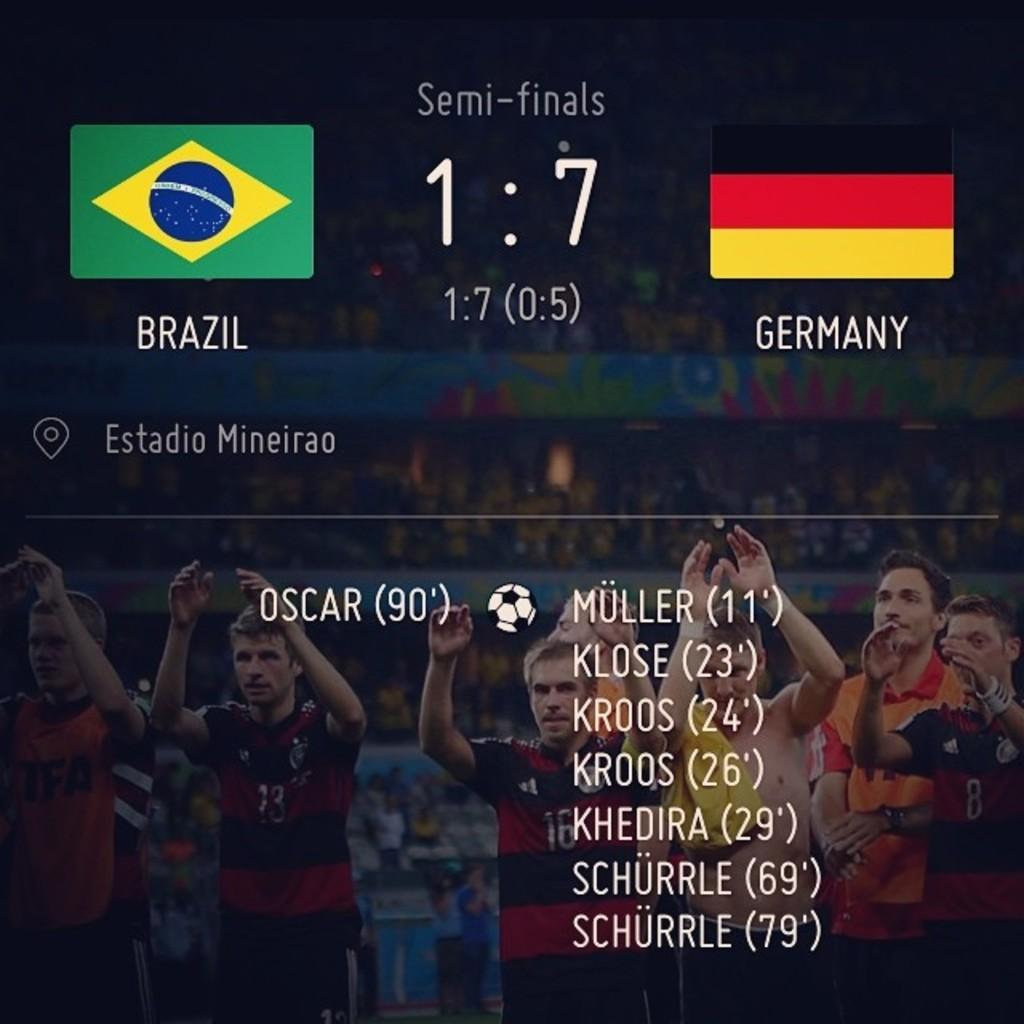What is the main subject of the image? The main subject of the image is a scorecard. What type of sport is the scorecard related to? The scorecard is related to a football match. What information can be found on the scorecard? The scorecard contains text and pictures of players. What type of instrument is being played by the players in the image? There are no instruments or players visible in the image; it only contains a scorecard related to a football match. 